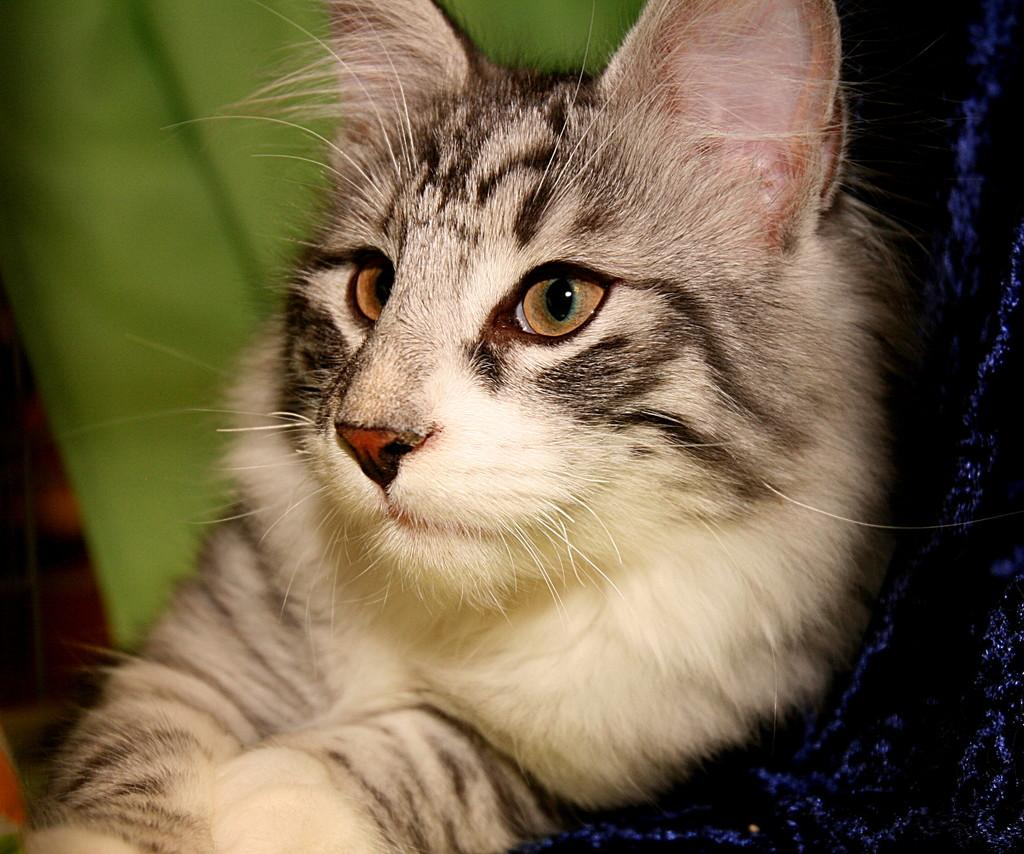What type of animal is present in the image? There is a cat in the image. What type of machine is visible in the image? There is no machine present in the image; it features a cat. What action is the cat performing in the image? The provided facts do not mention any specific action the cat is performing. 